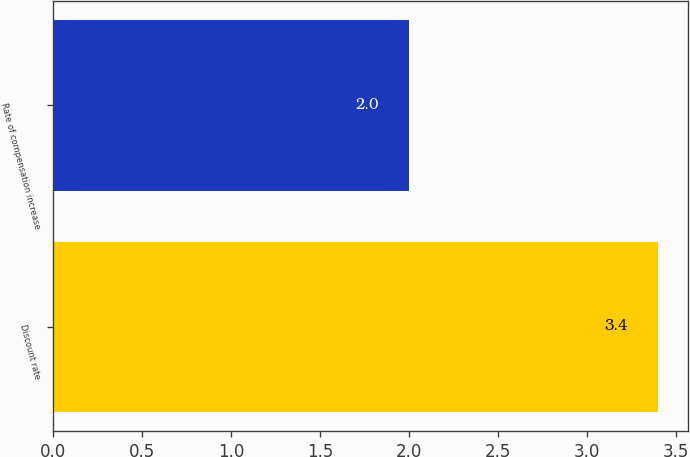Convert chart to OTSL. <chart><loc_0><loc_0><loc_500><loc_500><bar_chart><fcel>Discount rate<fcel>Rate of compensation increase<nl><fcel>3.4<fcel>2<nl></chart> 